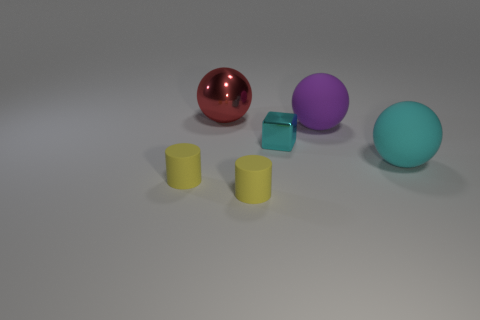The large thing that is to the left of the big cyan object and in front of the red metallic thing has what shape?
Provide a short and direct response. Sphere. Are there an equal number of matte objects that are on the right side of the metal cube and yellow rubber objects on the left side of the large red metallic sphere?
Offer a very short reply. No. What number of blocks are either large red shiny things or tiny metal objects?
Provide a short and direct response. 1. What number of large red spheres have the same material as the tiny cyan object?
Offer a terse response. 1. What is the thing that is both behind the tiny cube and on the left side of the big purple sphere made of?
Make the answer very short. Metal. What is the shape of the yellow matte thing to the right of the red object?
Keep it short and to the point. Cylinder. What shape is the cyan thing on the right side of the large purple ball that is in front of the metallic ball?
Make the answer very short. Sphere. Is there a large red thing of the same shape as the cyan metallic object?
Provide a short and direct response. No. What shape is the red metal thing that is the same size as the purple matte sphere?
Make the answer very short. Sphere. There is a thing that is on the left side of the large red object that is left of the purple rubber object; is there a metal thing in front of it?
Give a very brief answer. No. 